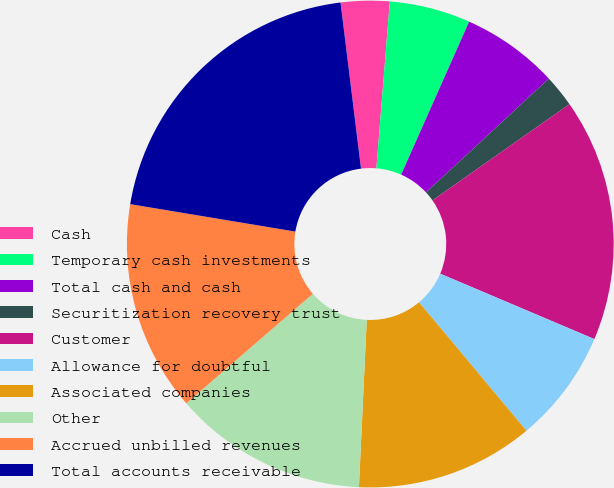<chart> <loc_0><loc_0><loc_500><loc_500><pie_chart><fcel>Cash<fcel>Temporary cash investments<fcel>Total cash and cash<fcel>Securitization recovery trust<fcel>Customer<fcel>Allowance for doubtful<fcel>Associated companies<fcel>Other<fcel>Accrued unbilled revenues<fcel>Total accounts receivable<nl><fcel>3.23%<fcel>5.38%<fcel>6.45%<fcel>2.15%<fcel>16.13%<fcel>7.53%<fcel>11.83%<fcel>12.9%<fcel>13.98%<fcel>20.43%<nl></chart> 